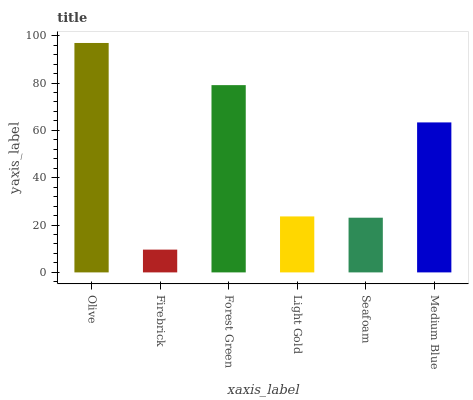Is Firebrick the minimum?
Answer yes or no. Yes. Is Olive the maximum?
Answer yes or no. Yes. Is Forest Green the minimum?
Answer yes or no. No. Is Forest Green the maximum?
Answer yes or no. No. Is Forest Green greater than Firebrick?
Answer yes or no. Yes. Is Firebrick less than Forest Green?
Answer yes or no. Yes. Is Firebrick greater than Forest Green?
Answer yes or no. No. Is Forest Green less than Firebrick?
Answer yes or no. No. Is Medium Blue the high median?
Answer yes or no. Yes. Is Light Gold the low median?
Answer yes or no. Yes. Is Olive the high median?
Answer yes or no. No. Is Medium Blue the low median?
Answer yes or no. No. 